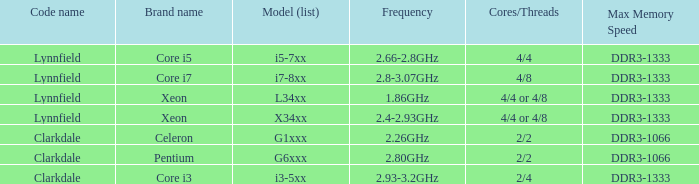What frequency does the Pentium processor use? 2.80GHz. 